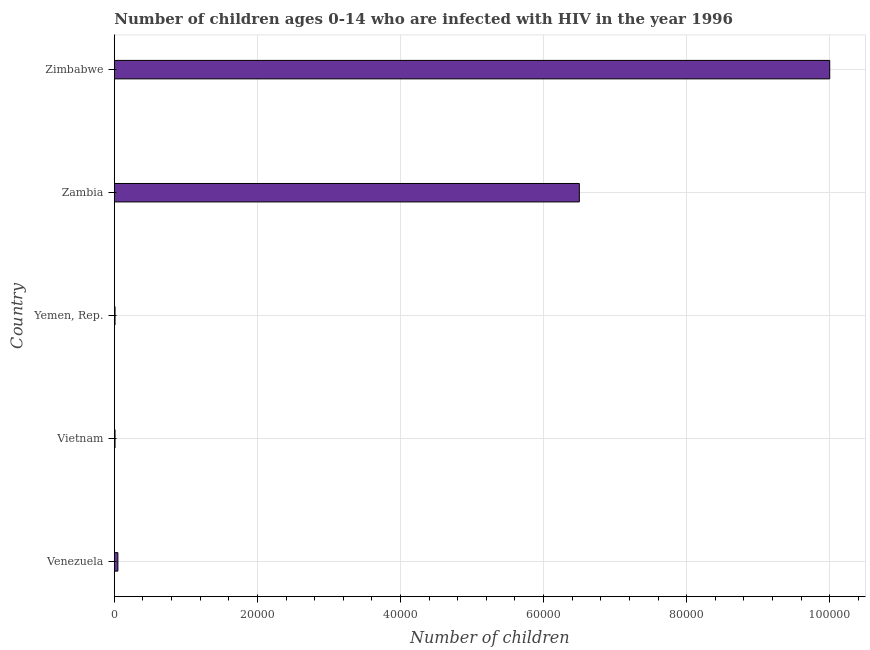Does the graph contain any zero values?
Your answer should be very brief. No. Does the graph contain grids?
Make the answer very short. Yes. What is the title of the graph?
Offer a terse response. Number of children ages 0-14 who are infected with HIV in the year 1996. What is the label or title of the X-axis?
Ensure brevity in your answer.  Number of children. What is the label or title of the Y-axis?
Offer a very short reply. Country. What is the number of children living with hiv in Venezuela?
Provide a short and direct response. 500. Across all countries, what is the maximum number of children living with hiv?
Your response must be concise. 1.00e+05. Across all countries, what is the minimum number of children living with hiv?
Provide a succinct answer. 100. In which country was the number of children living with hiv maximum?
Your answer should be compact. Zimbabwe. In which country was the number of children living with hiv minimum?
Provide a succinct answer. Vietnam. What is the sum of the number of children living with hiv?
Offer a very short reply. 1.66e+05. What is the difference between the number of children living with hiv in Vietnam and Zimbabwe?
Your answer should be very brief. -9.99e+04. What is the average number of children living with hiv per country?
Provide a short and direct response. 3.31e+04. What is the median number of children living with hiv?
Keep it short and to the point. 500. In how many countries, is the number of children living with hiv greater than 56000 ?
Your answer should be compact. 2. Is the number of children living with hiv in Venezuela less than that in Yemen, Rep.?
Keep it short and to the point. No. What is the difference between the highest and the second highest number of children living with hiv?
Provide a short and direct response. 3.50e+04. Is the sum of the number of children living with hiv in Vietnam and Yemen, Rep. greater than the maximum number of children living with hiv across all countries?
Your response must be concise. No. What is the difference between the highest and the lowest number of children living with hiv?
Ensure brevity in your answer.  9.99e+04. In how many countries, is the number of children living with hiv greater than the average number of children living with hiv taken over all countries?
Your answer should be compact. 2. Are all the bars in the graph horizontal?
Offer a very short reply. Yes. How many countries are there in the graph?
Provide a short and direct response. 5. What is the difference between two consecutive major ticks on the X-axis?
Provide a short and direct response. 2.00e+04. Are the values on the major ticks of X-axis written in scientific E-notation?
Offer a terse response. No. What is the Number of children of Yemen, Rep.?
Ensure brevity in your answer.  100. What is the Number of children in Zambia?
Provide a succinct answer. 6.50e+04. What is the difference between the Number of children in Venezuela and Yemen, Rep.?
Your response must be concise. 400. What is the difference between the Number of children in Venezuela and Zambia?
Provide a short and direct response. -6.45e+04. What is the difference between the Number of children in Venezuela and Zimbabwe?
Keep it short and to the point. -9.95e+04. What is the difference between the Number of children in Vietnam and Yemen, Rep.?
Provide a succinct answer. 0. What is the difference between the Number of children in Vietnam and Zambia?
Offer a terse response. -6.49e+04. What is the difference between the Number of children in Vietnam and Zimbabwe?
Ensure brevity in your answer.  -9.99e+04. What is the difference between the Number of children in Yemen, Rep. and Zambia?
Make the answer very short. -6.49e+04. What is the difference between the Number of children in Yemen, Rep. and Zimbabwe?
Your answer should be very brief. -9.99e+04. What is the difference between the Number of children in Zambia and Zimbabwe?
Offer a terse response. -3.50e+04. What is the ratio of the Number of children in Venezuela to that in Vietnam?
Your response must be concise. 5. What is the ratio of the Number of children in Venezuela to that in Yemen, Rep.?
Keep it short and to the point. 5. What is the ratio of the Number of children in Venezuela to that in Zambia?
Provide a succinct answer. 0.01. What is the ratio of the Number of children in Venezuela to that in Zimbabwe?
Make the answer very short. 0.01. What is the ratio of the Number of children in Vietnam to that in Zambia?
Offer a very short reply. 0. What is the ratio of the Number of children in Vietnam to that in Zimbabwe?
Your answer should be very brief. 0. What is the ratio of the Number of children in Yemen, Rep. to that in Zambia?
Keep it short and to the point. 0. What is the ratio of the Number of children in Yemen, Rep. to that in Zimbabwe?
Ensure brevity in your answer.  0. What is the ratio of the Number of children in Zambia to that in Zimbabwe?
Provide a short and direct response. 0.65. 